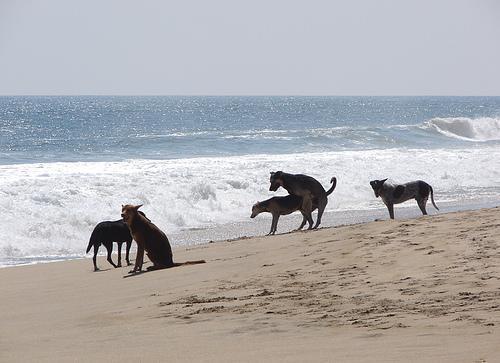How many white dogs are there?
Give a very brief answer. 0. 